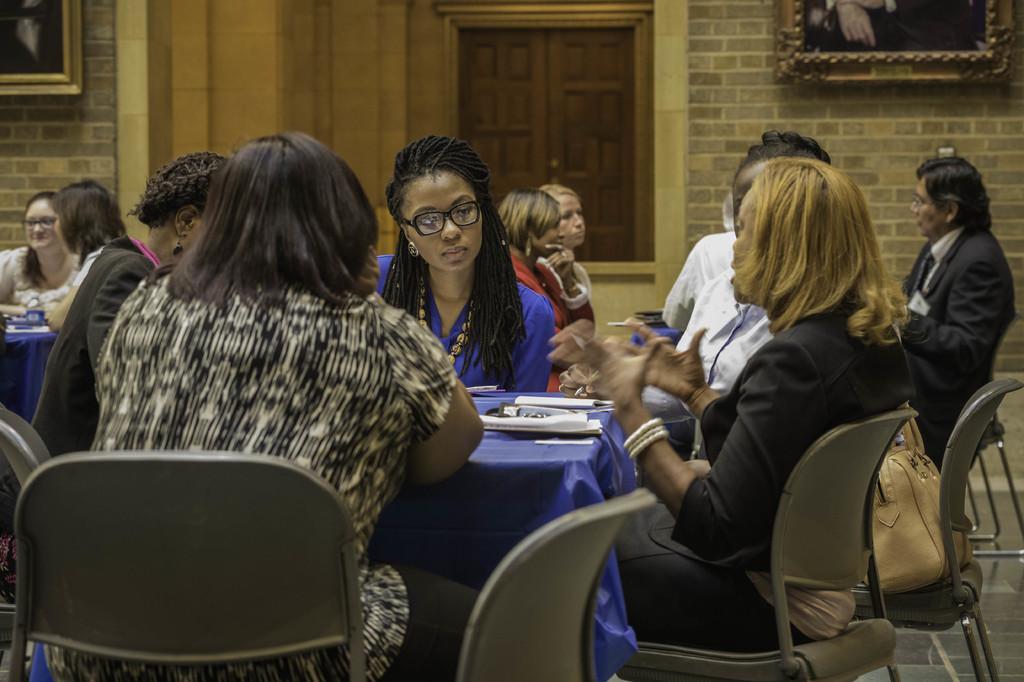Can you describe this image briefly? Group of people sitting on the chair and there is a bag on the chair and we can see papers on the table. ON the background we can see wall,frames,window. This is floor. 